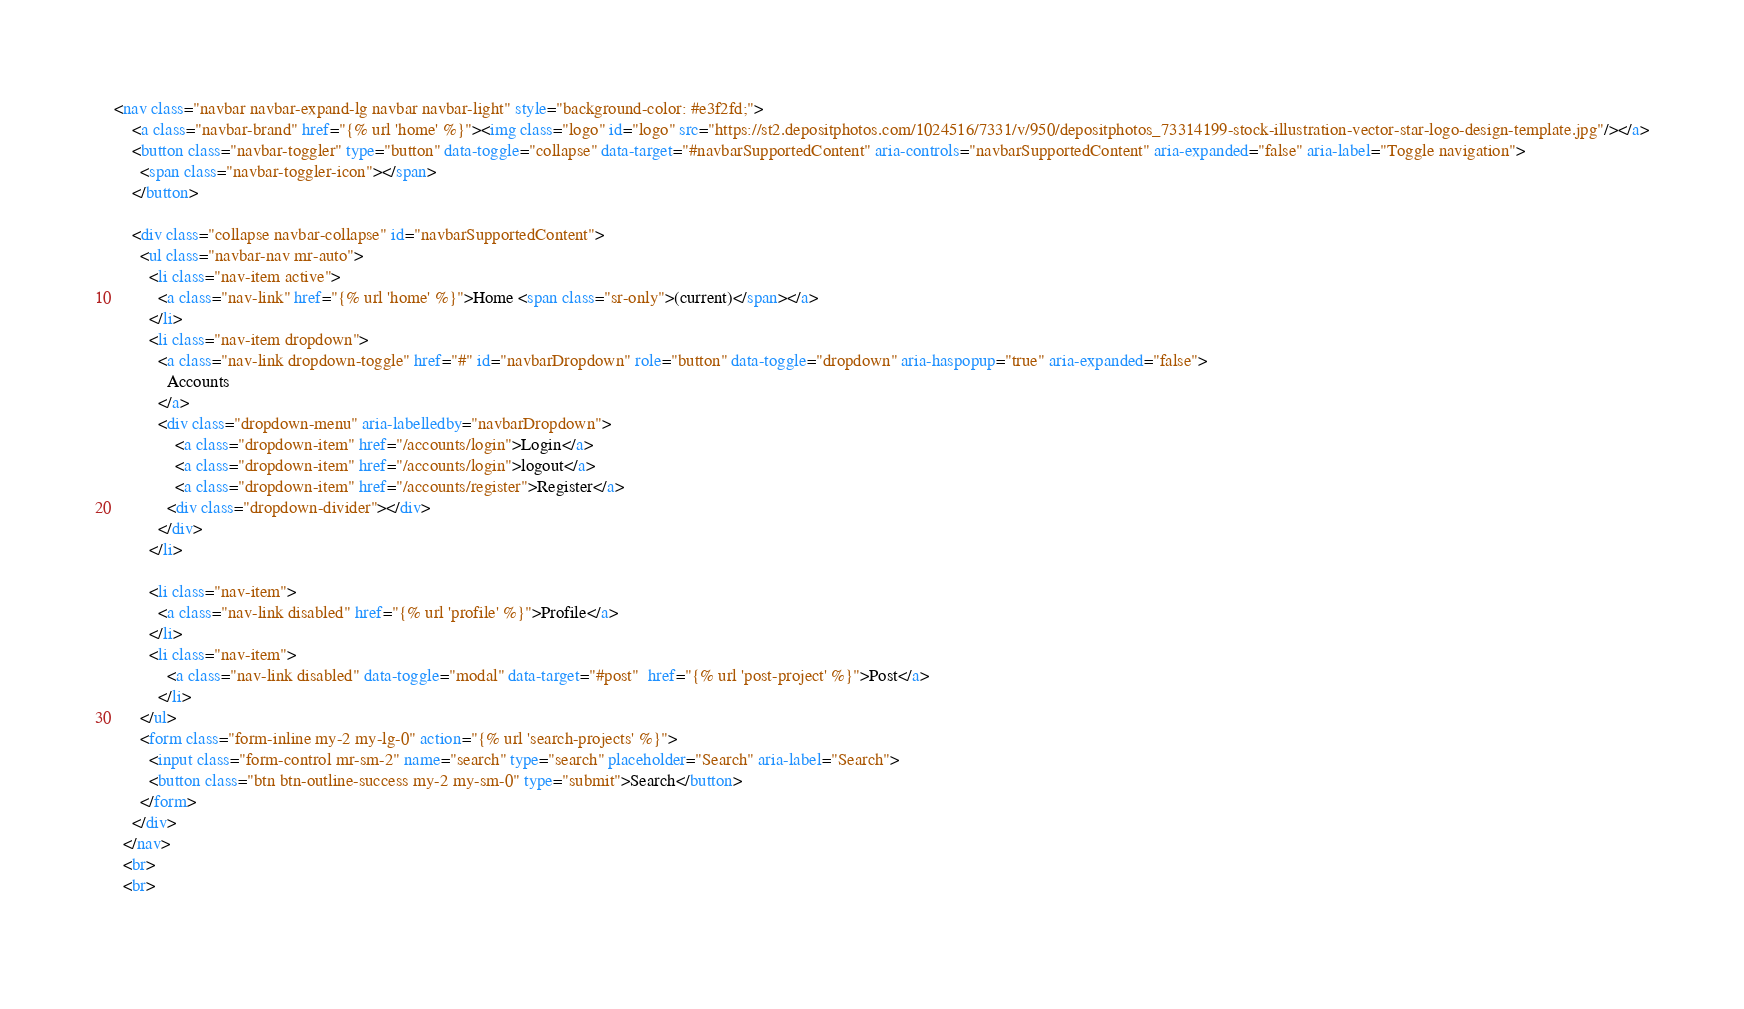<code> <loc_0><loc_0><loc_500><loc_500><_HTML_>
<nav class="navbar navbar-expand-lg navbar navbar-light" style="background-color: #e3f2fd;">
    <a class="navbar-brand" href="{% url 'home' %}"><img class="logo" id="logo" src="https://st2.depositphotos.com/1024516/7331/v/950/depositphotos_73314199-stock-illustration-vector-star-logo-design-template.jpg"/></a>
    <button class="navbar-toggler" type="button" data-toggle="collapse" data-target="#navbarSupportedContent" aria-controls="navbarSupportedContent" aria-expanded="false" aria-label="Toggle navigation">
      <span class="navbar-toggler-icon"></span>
    </button>
  
    <div class="collapse navbar-collapse" id="navbarSupportedContent">
      <ul class="navbar-nav mr-auto">
        <li class="nav-item active">
          <a class="nav-link" href="{% url 'home' %}">Home <span class="sr-only">(current)</span></a>
        </li>
        <li class="nav-item dropdown">
          <a class="nav-link dropdown-toggle" href="#" id="navbarDropdown" role="button" data-toggle="dropdown" aria-haspopup="true" aria-expanded="false">
            Accounts
          </a>
          <div class="dropdown-menu" aria-labelledby="navbarDropdown">
              <a class="dropdown-item" href="/accounts/login">Login</a>
              <a class="dropdown-item" href="/accounts/login">logout</a>
              <a class="dropdown-item" href="/accounts/register">Register</a>
            <div class="dropdown-divider"></div>
          </div>
        </li>
        
        <li class="nav-item">
          <a class="nav-link disabled" href="{% url 'profile' %}">Profile</a>
        </li>
        <li class="nav-item">
            <a class="nav-link disabled" data-toggle="modal" data-target="#post"  href="{% url 'post-project' %}">Post</a>
          </li>
      </ul>
      <form class="form-inline my-2 my-lg-0" action="{% url 'search-projects' %}">
        <input class="form-control mr-sm-2" name="search" type="search" placeholder="Search" aria-label="Search">
        <button class="btn btn-outline-success my-2 my-sm-0" type="submit">Search</button>
      </form>
    </div>
  </nav>
  <br>
  <br>              
              </code> 